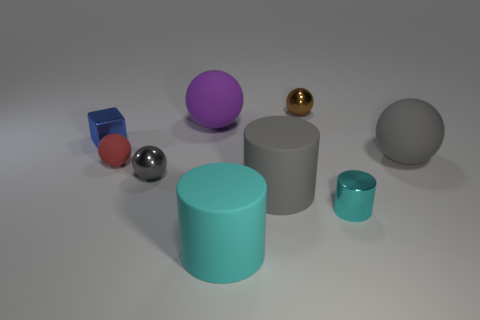Are there fewer small blue metal blocks that are right of the large cyan cylinder than tiny blue things that are in front of the brown ball?
Ensure brevity in your answer.  Yes. There is a rubber thing right of the tiny cyan thing; does it have the same shape as the red object?
Your answer should be compact. Yes. Are there any other things that have the same material as the red ball?
Offer a terse response. Yes. Are the large ball on the right side of the large cyan thing and the tiny gray ball made of the same material?
Make the answer very short. No. The gray ball that is left of the large rubber cylinder in front of the big rubber cylinder that is right of the cyan rubber cylinder is made of what material?
Ensure brevity in your answer.  Metal. What number of other objects are there of the same shape as the gray metal thing?
Provide a succinct answer. 4. The large object in front of the cyan shiny thing is what color?
Your response must be concise. Cyan. What number of large rubber balls are to the right of the small sphere that is on the right side of the cyan thing that is to the left of the large gray rubber cylinder?
Your answer should be compact. 1. What number of small brown balls are behind the small metal object that is in front of the large gray matte cylinder?
Provide a short and direct response. 1. What number of gray matte balls are behind the tiny blue cube?
Ensure brevity in your answer.  0. 